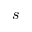<formula> <loc_0><loc_0><loc_500><loc_500>s</formula> 